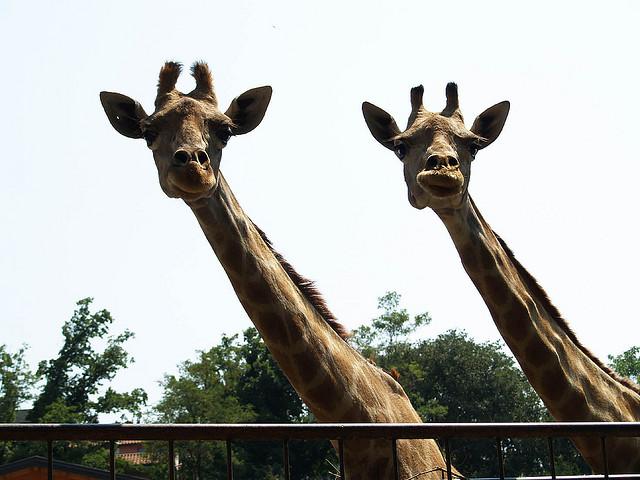How many animals?
Quick response, please. 2. What is behind the giraffes?
Answer briefly. Trees. Are the Giraffe's looking at the camera?
Concise answer only. Yes. Are there giraffe's in a cage?
Be succinct. Yes. How many animals are in the photo?
Answer briefly. 2. 